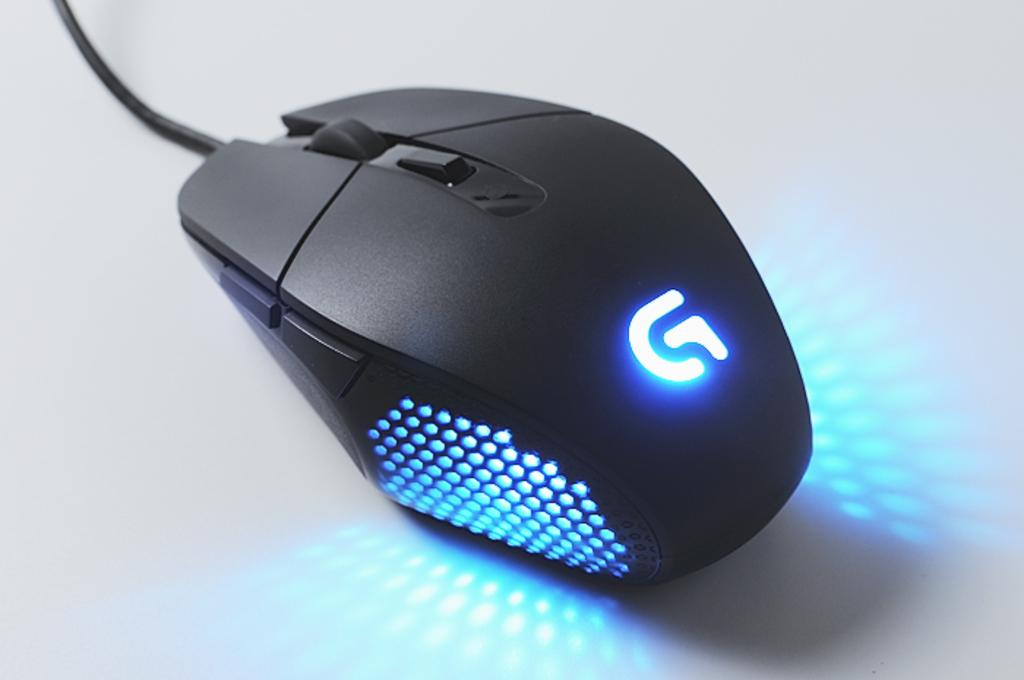<image>
Write a terse but informative summary of the picture. A black mouse has a lighted G on the front. 